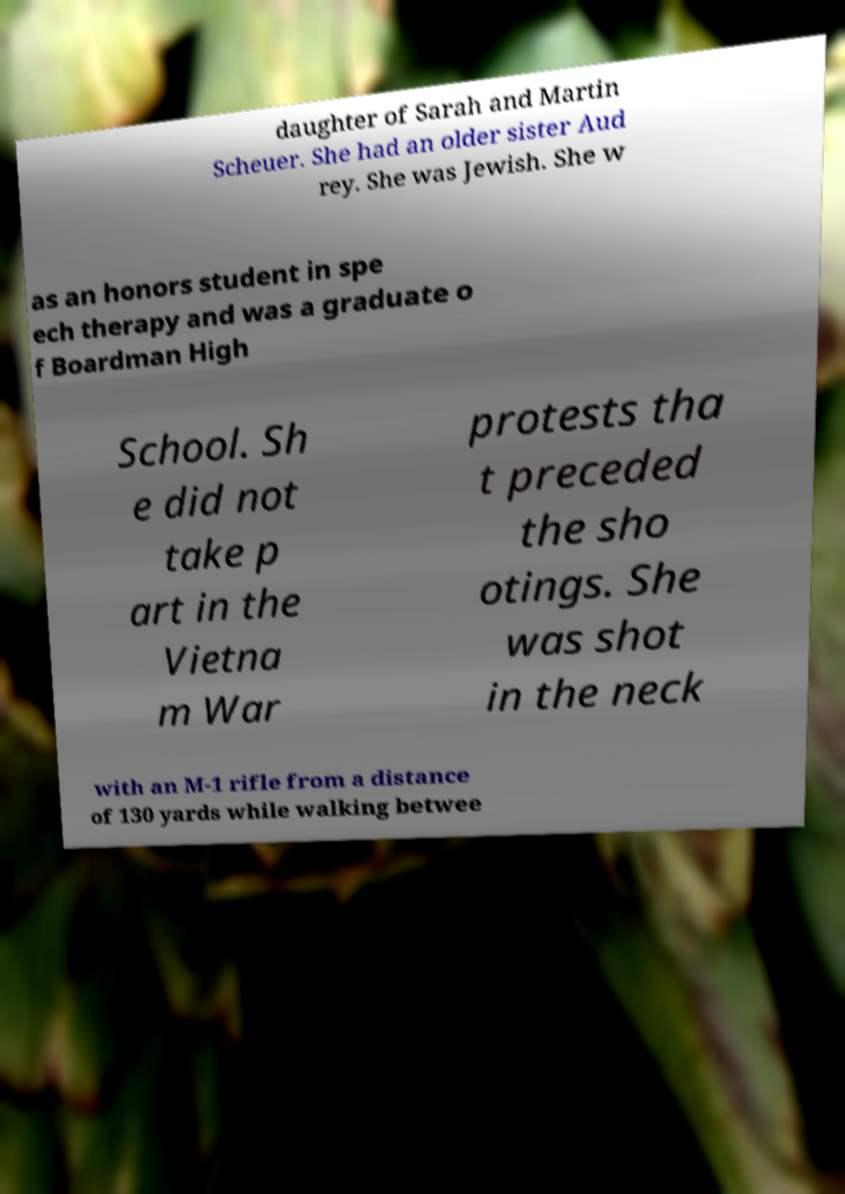For documentation purposes, I need the text within this image transcribed. Could you provide that? daughter of Sarah and Martin Scheuer. She had an older sister Aud rey. She was Jewish. She w as an honors student in spe ech therapy and was a graduate o f Boardman High School. Sh e did not take p art in the Vietna m War protests tha t preceded the sho otings. She was shot in the neck with an M-1 rifle from a distance of 130 yards while walking betwee 